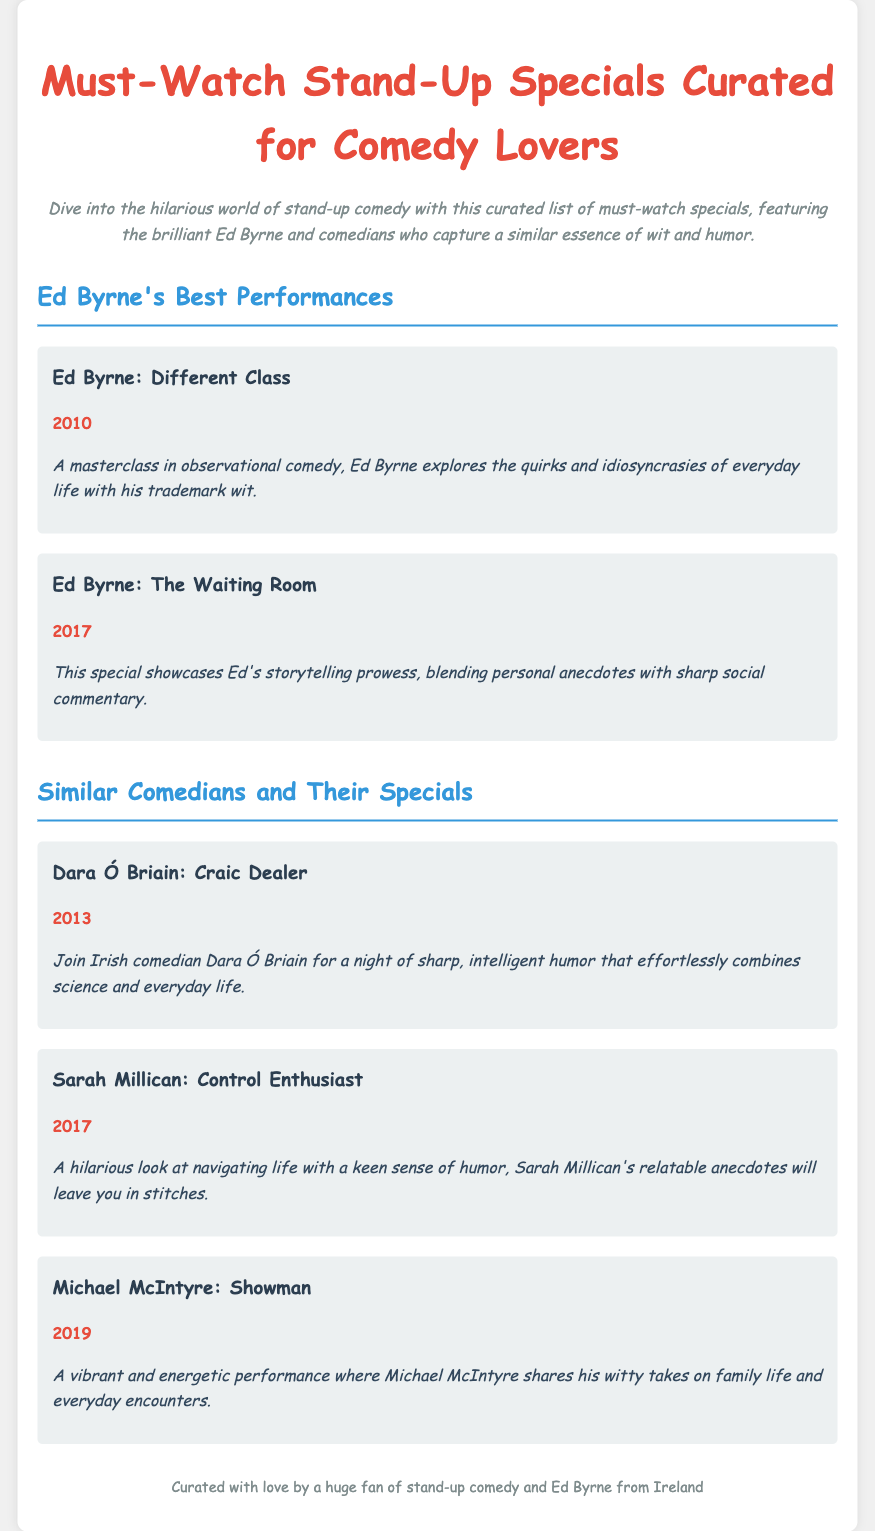What is the title of Ed Byrne's special from 2010? The title is mentioned as part of Ed Byrne's best performances in the document.
Answer: Different Class What is the year of Ed Byrne's special "The Waiting Room"? The year is provided in the details of Ed Byrne's performances.
Answer: 2017 Who is the comedian featured with the special "Craic Dealer"? This information is found in the section about similar comedians and their specials.
Answer: Dara Ó Briain What type of humor does Sarah Millican focus on in "Control Enthusiast"? This is described in the description of Sarah Millican's special in the document.
Answer: Relatable anecdotes Which comedian shares witty takes on family life in their performance? This detail is mentioned in the recommendation section about the comedians.
Answer: Michael McIntyre What year was the special "Showman" released? The year is specified under Michael McIntyre's recommendation.
Answer: 2019 How many stand-up specials by Ed Byrne are listed? The count can be determined from the performances section.
Answer: 2 What is the primary theme of Ed Byrne's comedy? The description of Ed Byrne's comedy can provide insight into the themes he explores.
Answer: Observational comedy Who curated the list in the footer of the document? The footer provides information about the curator of the list.
Answer: A huge fan of stand-up comedy and Ed Byrne from Ireland 